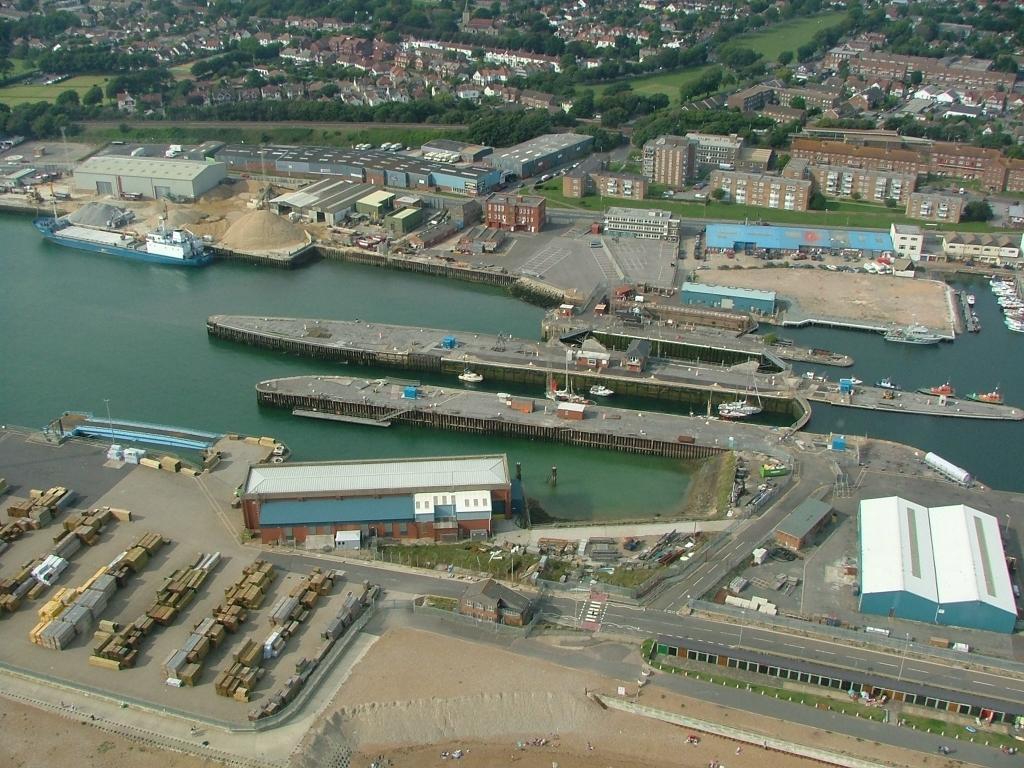Please provide a concise description of this image. This is an outside view. In the middle of the image there is a river and I can see some boats. At the bottom I can see few vehicles on the road. In the background, I can see many trees and buildings. 